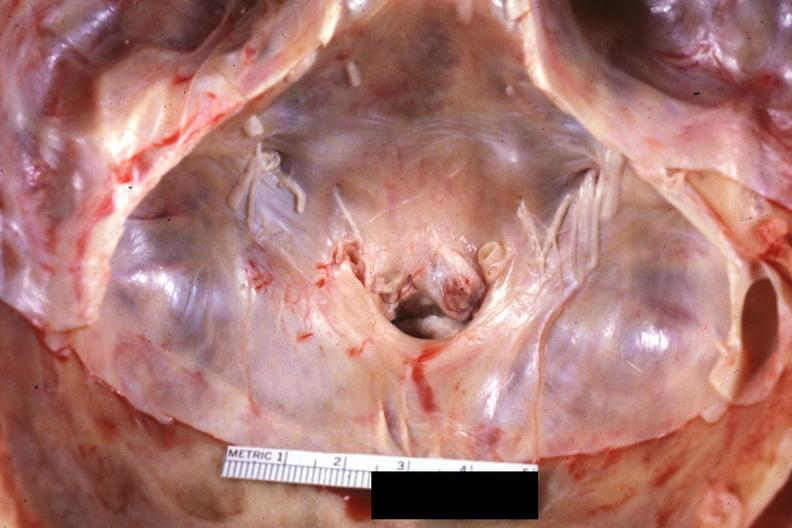s rheumatoid arthritis present?
Answer the question using a single word or phrase. Yes 